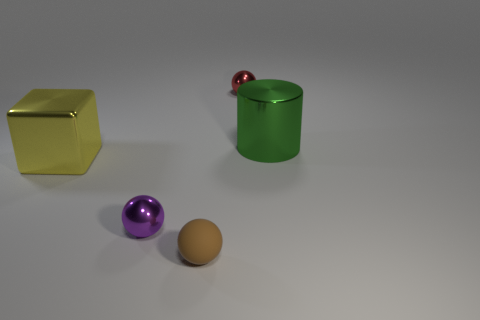Is the shape of the tiny metallic object on the left side of the red metallic sphere the same as the metal thing that is behind the green cylinder?
Offer a very short reply. Yes. What is the color of the thing that is in front of the red metallic ball and to the right of the brown matte object?
Provide a succinct answer. Green. Is the size of the metal ball behind the big yellow metallic thing the same as the metal thing that is to the left of the small purple object?
Offer a terse response. No. How many large things are either metal blocks or rubber things?
Your answer should be compact. 1. Is the material of the big thing left of the small red metal ball the same as the tiny brown thing?
Offer a very short reply. No. What is the color of the shiny ball that is in front of the big green object?
Ensure brevity in your answer.  Purple. Is there a yellow metallic thing of the same size as the metallic cube?
Your answer should be compact. No. What material is the brown object that is the same size as the purple sphere?
Offer a very short reply. Rubber. There is a green thing; is it the same size as the object left of the purple sphere?
Ensure brevity in your answer.  Yes. There is a large thing in front of the big green metallic object; what material is it?
Provide a succinct answer. Metal. 